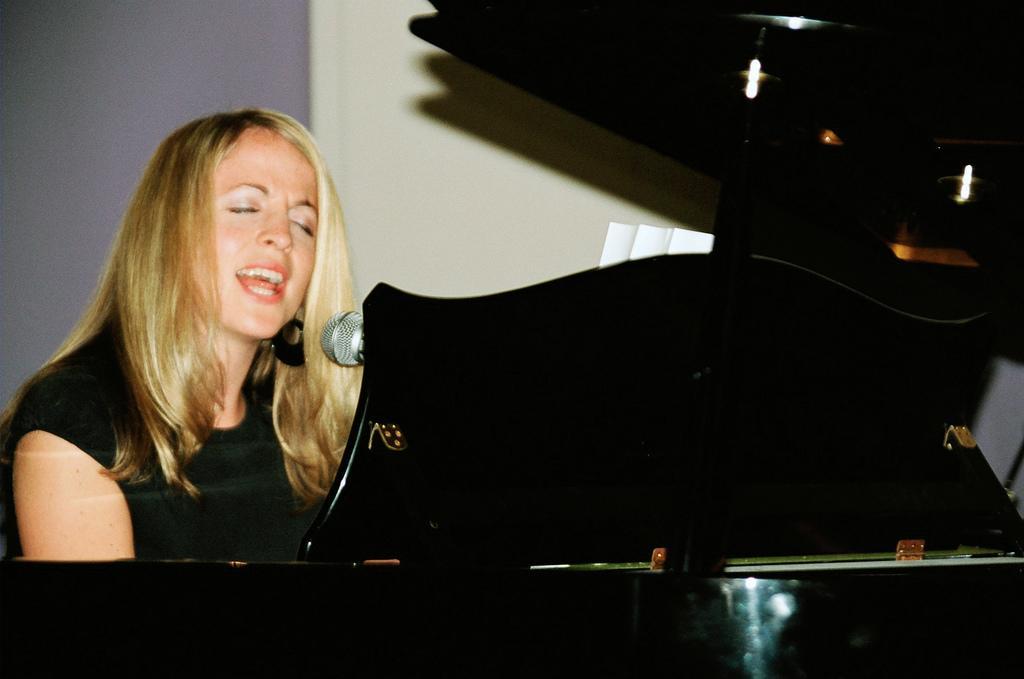Can you describe this image briefly? This woman Is playing an instrument and singing with the help of a microphone 